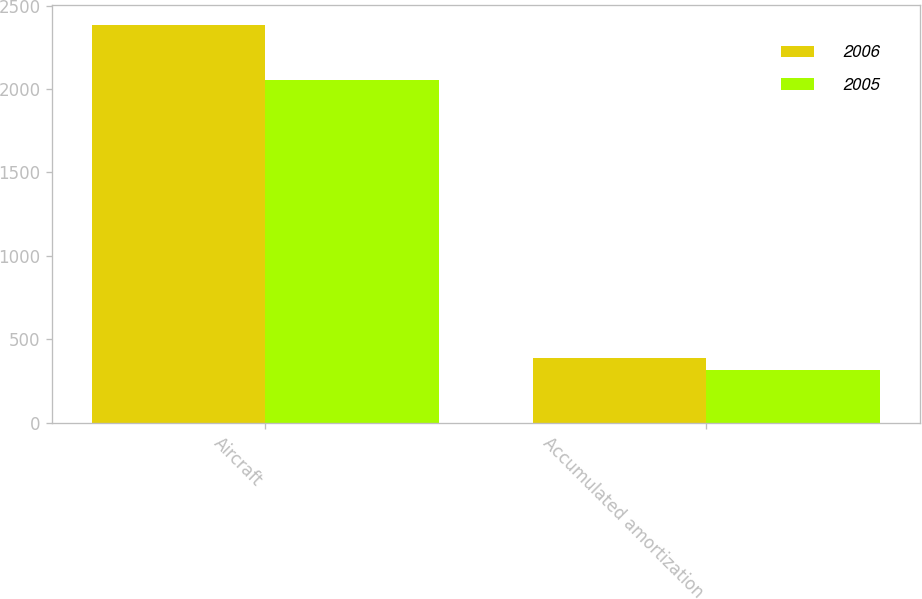Convert chart. <chart><loc_0><loc_0><loc_500><loc_500><stacked_bar_chart><ecel><fcel>Aircraft<fcel>Accumulated amortization<nl><fcel>2006<fcel>2383<fcel>390<nl><fcel>2005<fcel>2054<fcel>315<nl></chart> 